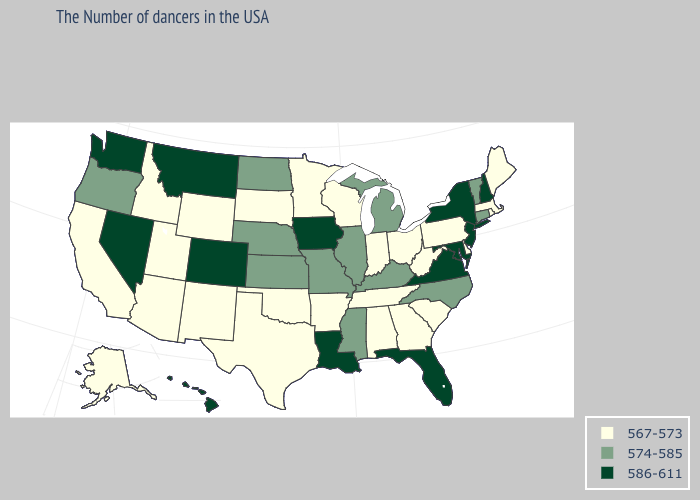What is the value of Washington?
Answer briefly. 586-611. Which states have the lowest value in the USA?
Concise answer only. Maine, Massachusetts, Rhode Island, Delaware, Pennsylvania, South Carolina, West Virginia, Ohio, Georgia, Indiana, Alabama, Tennessee, Wisconsin, Arkansas, Minnesota, Oklahoma, Texas, South Dakota, Wyoming, New Mexico, Utah, Arizona, Idaho, California, Alaska. Does Illinois have a lower value than Virginia?
Concise answer only. Yes. Which states have the lowest value in the West?
Answer briefly. Wyoming, New Mexico, Utah, Arizona, Idaho, California, Alaska. Which states have the lowest value in the Northeast?
Quick response, please. Maine, Massachusetts, Rhode Island, Pennsylvania. Name the states that have a value in the range 567-573?
Quick response, please. Maine, Massachusetts, Rhode Island, Delaware, Pennsylvania, South Carolina, West Virginia, Ohio, Georgia, Indiana, Alabama, Tennessee, Wisconsin, Arkansas, Minnesota, Oklahoma, Texas, South Dakota, Wyoming, New Mexico, Utah, Arizona, Idaho, California, Alaska. Name the states that have a value in the range 567-573?
Be succinct. Maine, Massachusetts, Rhode Island, Delaware, Pennsylvania, South Carolina, West Virginia, Ohio, Georgia, Indiana, Alabama, Tennessee, Wisconsin, Arkansas, Minnesota, Oklahoma, Texas, South Dakota, Wyoming, New Mexico, Utah, Arizona, Idaho, California, Alaska. Among the states that border Nevada , which have the highest value?
Write a very short answer. Oregon. Does West Virginia have the highest value in the South?
Quick response, please. No. Does Oklahoma have the highest value in the USA?
Give a very brief answer. No. Which states have the lowest value in the USA?
Answer briefly. Maine, Massachusetts, Rhode Island, Delaware, Pennsylvania, South Carolina, West Virginia, Ohio, Georgia, Indiana, Alabama, Tennessee, Wisconsin, Arkansas, Minnesota, Oklahoma, Texas, South Dakota, Wyoming, New Mexico, Utah, Arizona, Idaho, California, Alaska. Does the first symbol in the legend represent the smallest category?
Answer briefly. Yes. Does Delaware have the same value as Ohio?
Quick response, please. Yes. Does South Dakota have the lowest value in the USA?
Be succinct. Yes. 